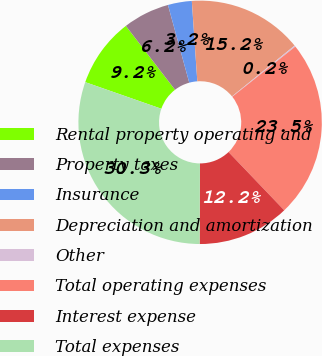Convert chart to OTSL. <chart><loc_0><loc_0><loc_500><loc_500><pie_chart><fcel>Rental property operating and<fcel>Property taxes<fcel>Insurance<fcel>Depreciation and amortization<fcel>Other<fcel>Total operating expenses<fcel>Interest expense<fcel>Total expenses<nl><fcel>9.2%<fcel>6.19%<fcel>3.17%<fcel>15.23%<fcel>0.16%<fcel>23.55%<fcel>12.21%<fcel>30.29%<nl></chart> 